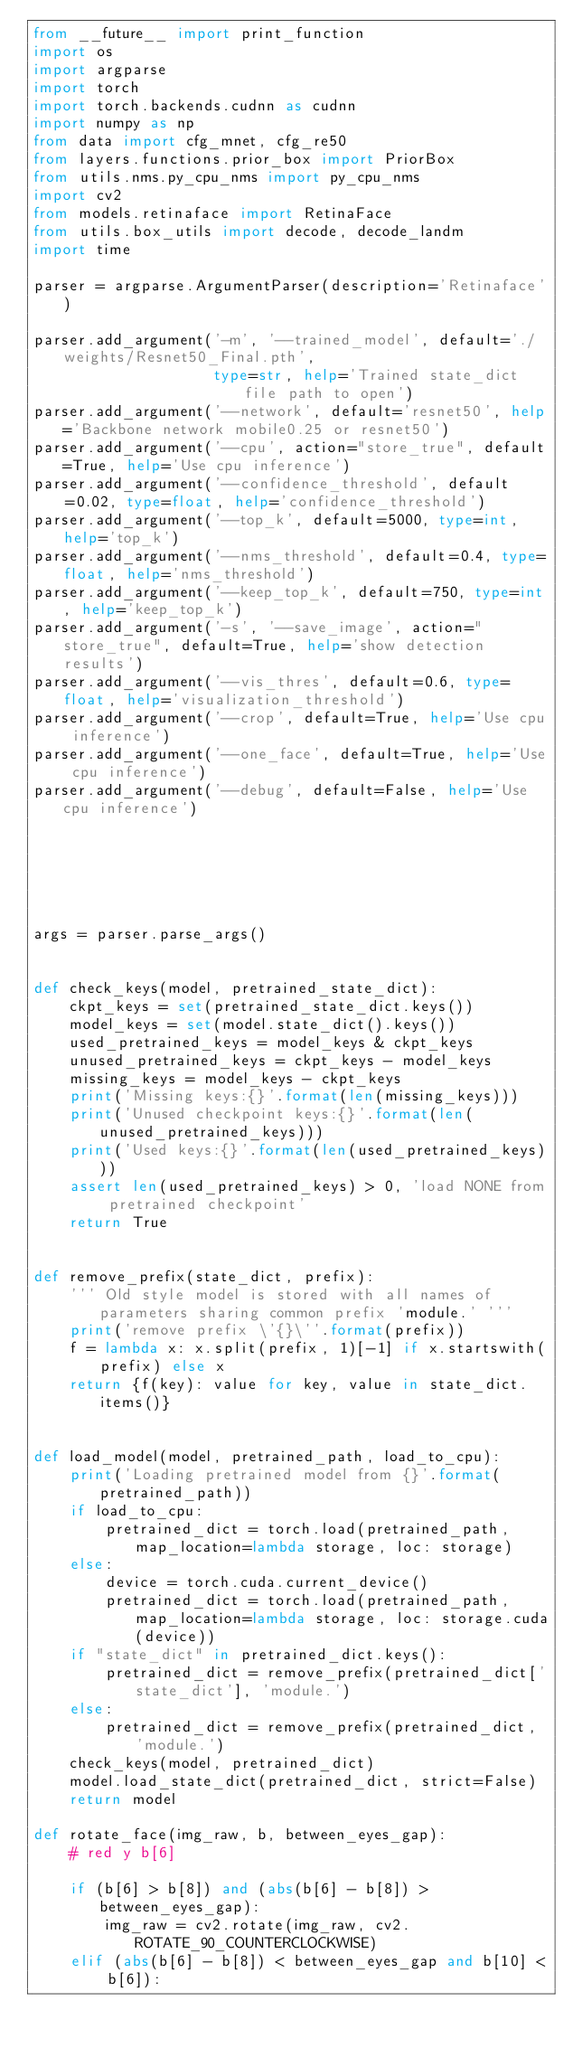<code> <loc_0><loc_0><loc_500><loc_500><_Python_>from __future__ import print_function
import os
import argparse
import torch
import torch.backends.cudnn as cudnn
import numpy as np
from data import cfg_mnet, cfg_re50
from layers.functions.prior_box import PriorBox
from utils.nms.py_cpu_nms import py_cpu_nms
import cv2
from models.retinaface import RetinaFace
from utils.box_utils import decode, decode_landm
import time

parser = argparse.ArgumentParser(description='Retinaface')

parser.add_argument('-m', '--trained_model', default='./weights/Resnet50_Final.pth',
                    type=str, help='Trained state_dict file path to open')
parser.add_argument('--network', default='resnet50', help='Backbone network mobile0.25 or resnet50')
parser.add_argument('--cpu', action="store_true", default=True, help='Use cpu inference')
parser.add_argument('--confidence_threshold', default=0.02, type=float, help='confidence_threshold')
parser.add_argument('--top_k', default=5000, type=int, help='top_k')
parser.add_argument('--nms_threshold', default=0.4, type=float, help='nms_threshold')
parser.add_argument('--keep_top_k', default=750, type=int, help='keep_top_k')
parser.add_argument('-s', '--save_image', action="store_true", default=True, help='show detection results')
parser.add_argument('--vis_thres', default=0.6, type=float, help='visualization_threshold')
parser.add_argument('--crop', default=True, help='Use cpu inference')
parser.add_argument('--one_face', default=True, help='Use cpu inference')
parser.add_argument('--debug', default=False, help='Use cpu inference')






args = parser.parse_args()


def check_keys(model, pretrained_state_dict):
    ckpt_keys = set(pretrained_state_dict.keys())
    model_keys = set(model.state_dict().keys())
    used_pretrained_keys = model_keys & ckpt_keys
    unused_pretrained_keys = ckpt_keys - model_keys
    missing_keys = model_keys - ckpt_keys
    print('Missing keys:{}'.format(len(missing_keys)))
    print('Unused checkpoint keys:{}'.format(len(unused_pretrained_keys)))
    print('Used keys:{}'.format(len(used_pretrained_keys)))
    assert len(used_pretrained_keys) > 0, 'load NONE from pretrained checkpoint'
    return True


def remove_prefix(state_dict, prefix):
    ''' Old style model is stored with all names of parameters sharing common prefix 'module.' '''
    print('remove prefix \'{}\''.format(prefix))
    f = lambda x: x.split(prefix, 1)[-1] if x.startswith(prefix) else x
    return {f(key): value for key, value in state_dict.items()}


def load_model(model, pretrained_path, load_to_cpu):
    print('Loading pretrained model from {}'.format(pretrained_path))
    if load_to_cpu:
        pretrained_dict = torch.load(pretrained_path, map_location=lambda storage, loc: storage)
    else:
        device = torch.cuda.current_device()
        pretrained_dict = torch.load(pretrained_path, map_location=lambda storage, loc: storage.cuda(device))
    if "state_dict" in pretrained_dict.keys():
        pretrained_dict = remove_prefix(pretrained_dict['state_dict'], 'module.')
    else:
        pretrained_dict = remove_prefix(pretrained_dict, 'module.')
    check_keys(model, pretrained_dict)
    model.load_state_dict(pretrained_dict, strict=False)
    return model

def rotate_face(img_raw, b, between_eyes_gap):
    # red y b[6]

    if (b[6] > b[8]) and (abs(b[6] - b[8]) > between_eyes_gap):
        img_raw = cv2.rotate(img_raw, cv2.ROTATE_90_COUNTERCLOCKWISE)
    elif (abs(b[6] - b[8]) < between_eyes_gap and b[10] < b[6]):</code> 